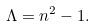<formula> <loc_0><loc_0><loc_500><loc_500>\Lambda = n ^ { 2 } - 1 .</formula> 